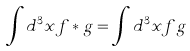Convert formula to latex. <formula><loc_0><loc_0><loc_500><loc_500>\int d ^ { 3 } x f * g = \int d ^ { 3 } x f g</formula> 